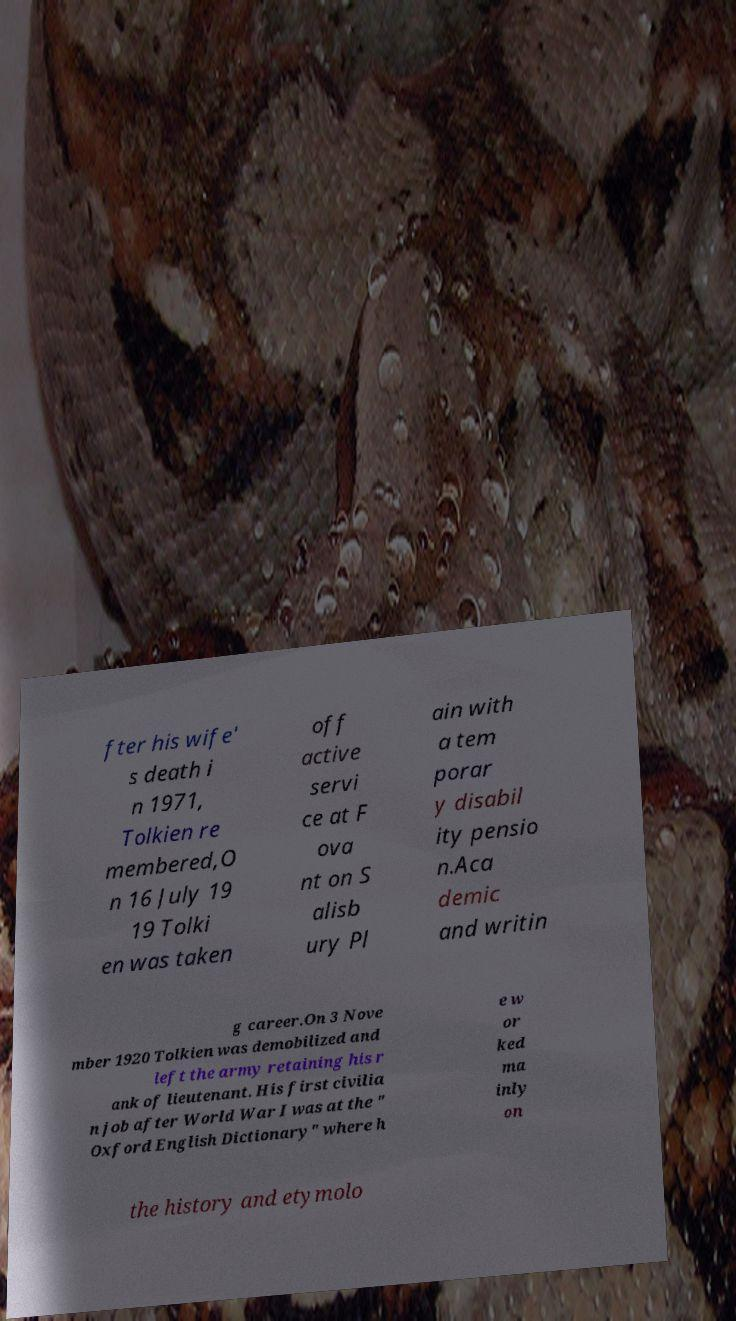Please read and relay the text visible in this image. What does it say? fter his wife' s death i n 1971, Tolkien re membered,O n 16 July 19 19 Tolki en was taken off active servi ce at F ova nt on S alisb ury Pl ain with a tem porar y disabil ity pensio n.Aca demic and writin g career.On 3 Nove mber 1920 Tolkien was demobilized and left the army retaining his r ank of lieutenant. His first civilia n job after World War I was at the " Oxford English Dictionary" where h e w or ked ma inly on the history and etymolo 